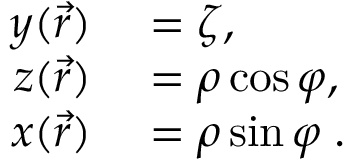<formula> <loc_0><loc_0><loc_500><loc_500>\begin{array} { r l } { y ( \vec { r } ) } & = \zeta , } \\ { z ( \vec { r } ) } & = \rho \cos \varphi , } \\ { x ( \vec { r } ) } & = \rho \sin \varphi \, . } \end{array}</formula> 